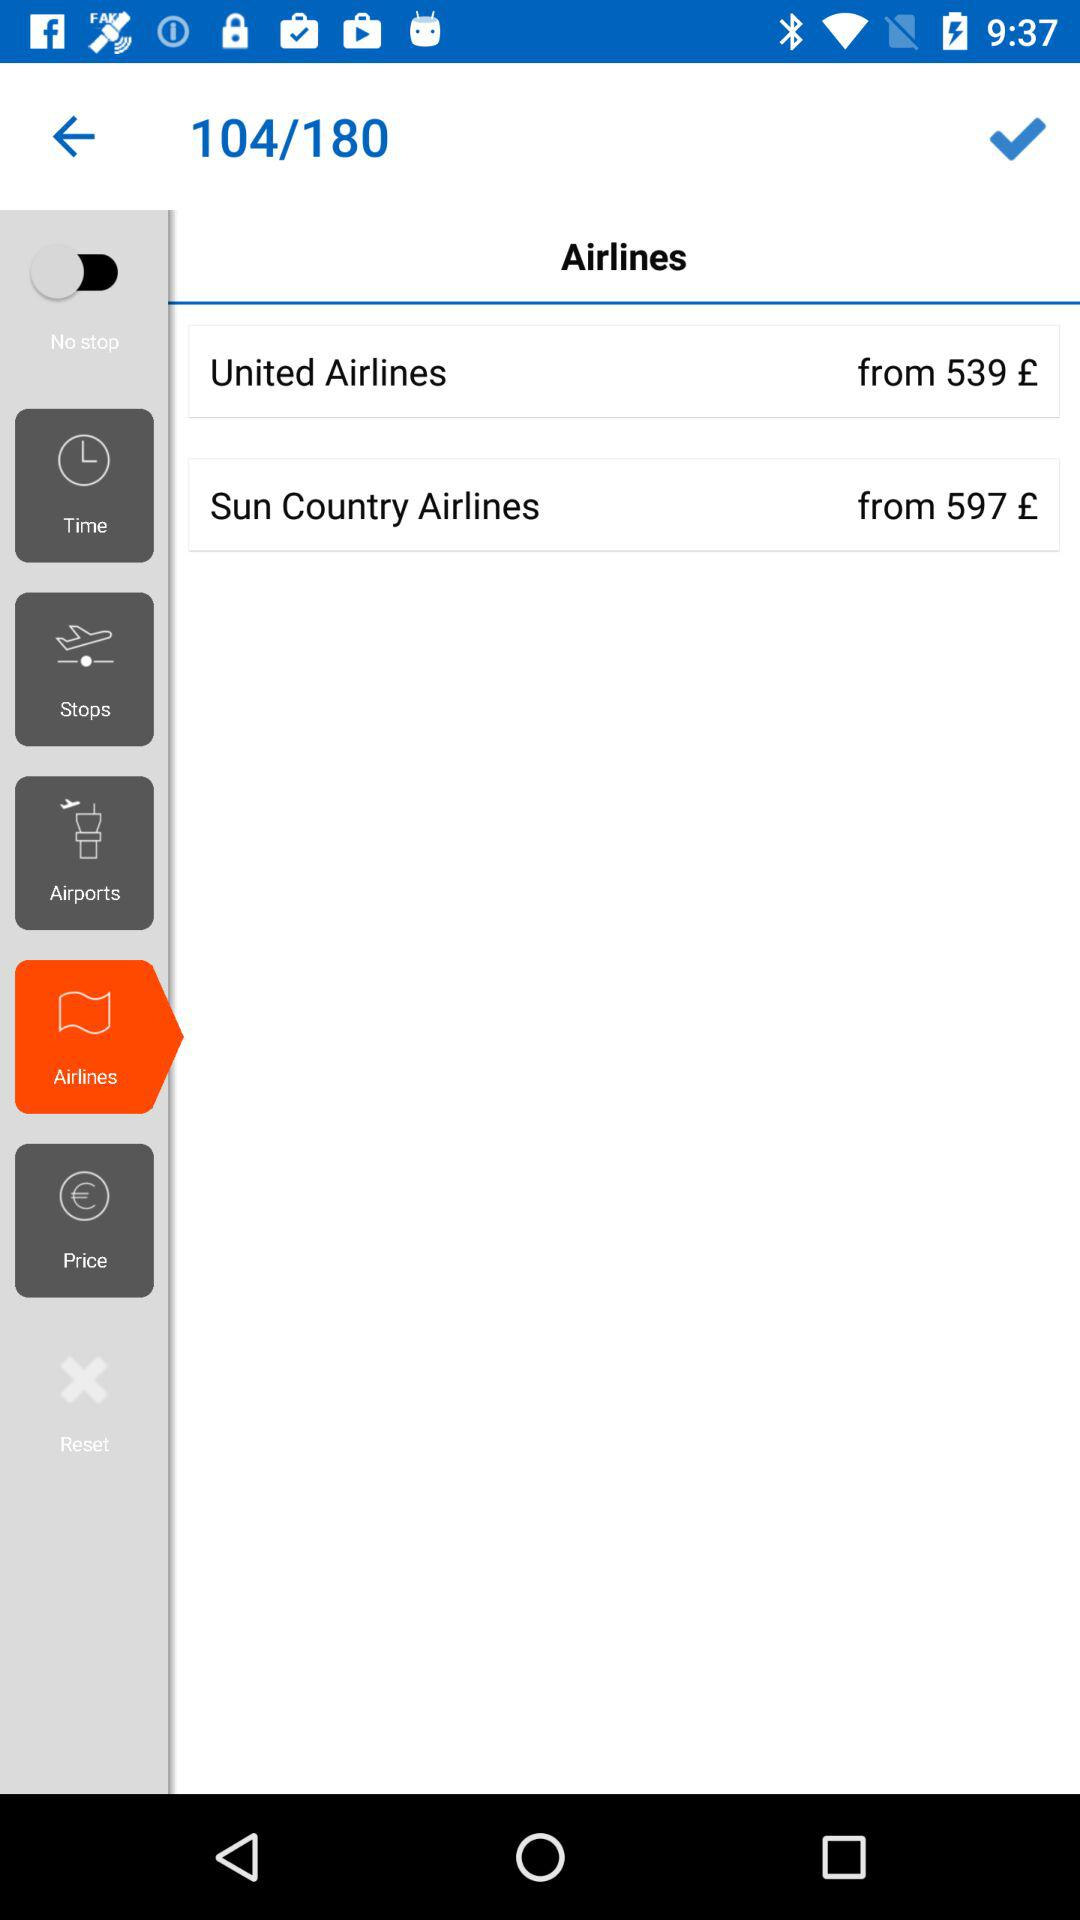What's the starting price for the "Sun Country Airlines" ticket? The starting price for the "Sun Country Airlines" ticket is 597 pounds. 